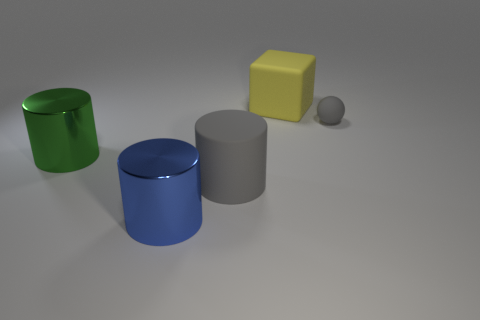Subtract all brown balls. Subtract all gray cylinders. How many balls are left? 1 Add 5 yellow blocks. How many objects exist? 10 Subtract all cylinders. How many objects are left? 2 Add 2 big green metal objects. How many big green metal objects exist? 3 Subtract 0 red cylinders. How many objects are left? 5 Subtract all blue metal cylinders. Subtract all tiny objects. How many objects are left? 3 Add 3 big rubber cylinders. How many big rubber cylinders are left? 4 